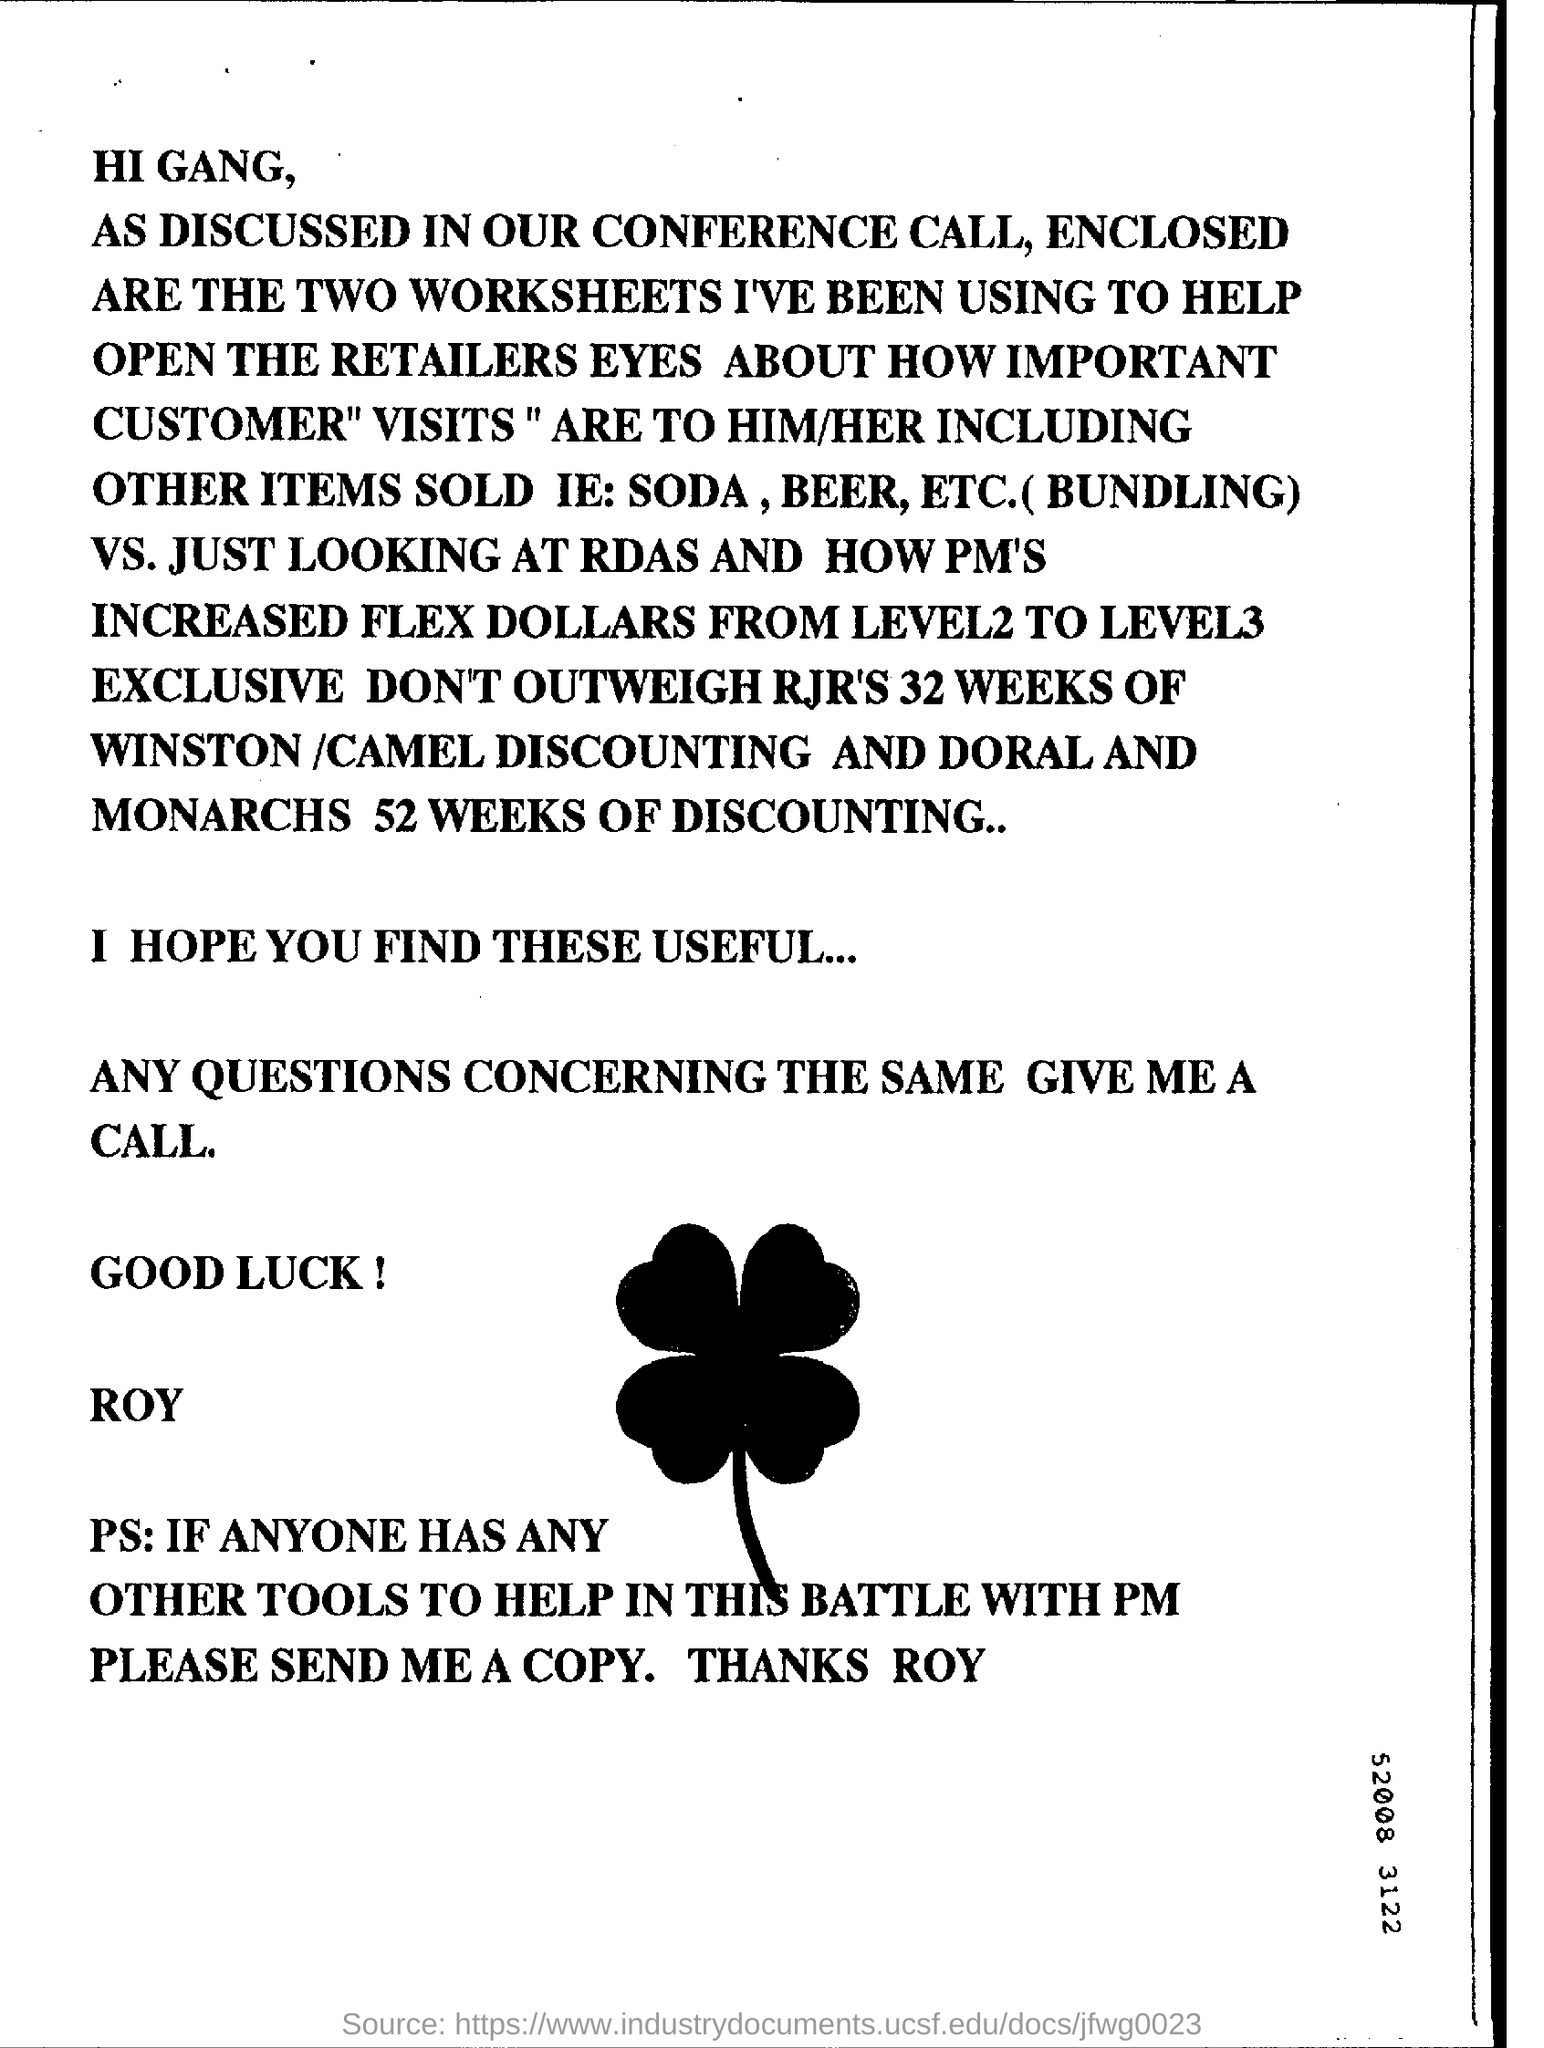Specify some key components in this picture. For the Doral and Monarch brands of cigarettes, a total of 52 weeks of discounting was given. The letter encloses two worksheets. The Winston /Camel brand of cigarettes was given a discount of 32 weeks. The person who sent the letter is ROY. 